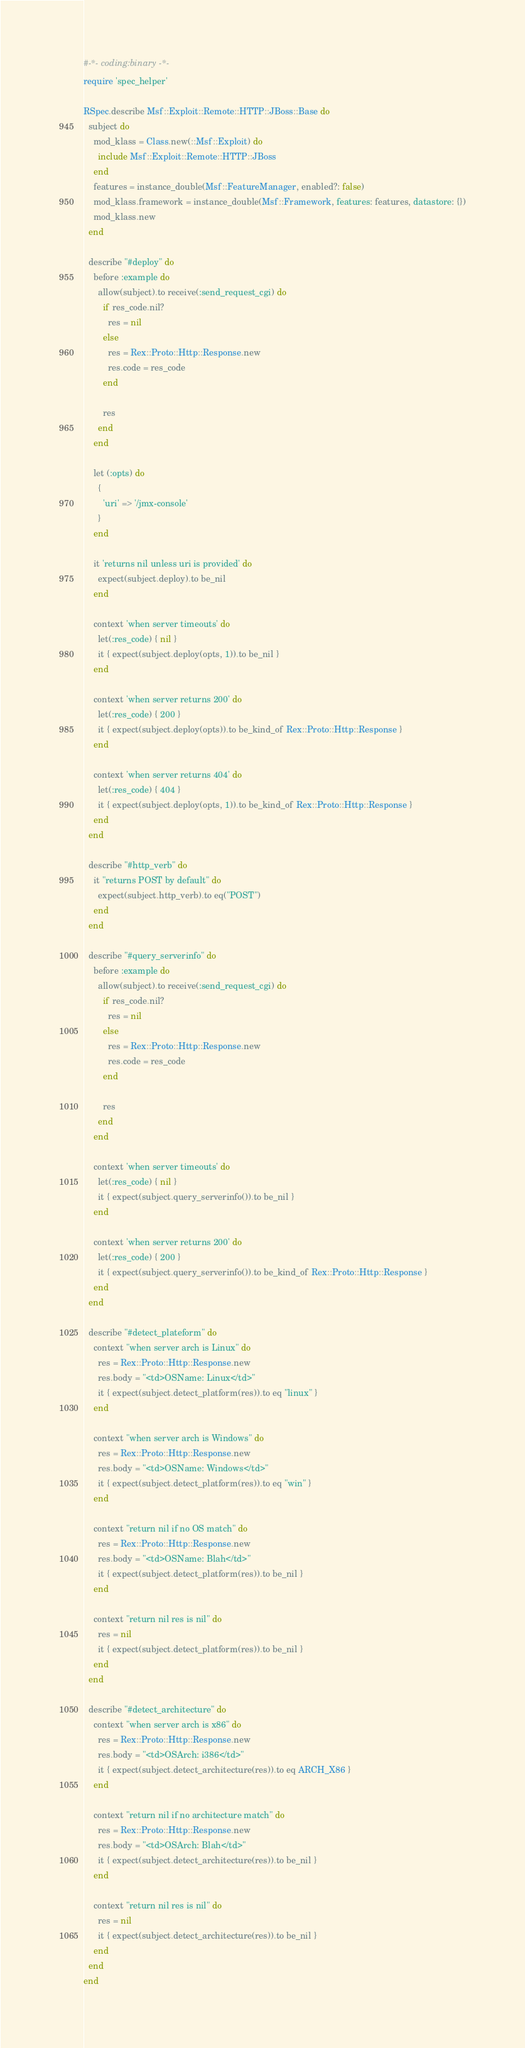Convert code to text. <code><loc_0><loc_0><loc_500><loc_500><_Ruby_>#-*- coding:binary -*-
require 'spec_helper'

RSpec.describe Msf::Exploit::Remote::HTTP::JBoss::Base do
  subject do
    mod_klass = Class.new(::Msf::Exploit) do
      include Msf::Exploit::Remote::HTTP::JBoss
    end
    features = instance_double(Msf::FeatureManager, enabled?: false)
    mod_klass.framework = instance_double(Msf::Framework, features: features, datastore: {})
    mod_klass.new
  end

  describe "#deploy" do
    before :example do
      allow(subject).to receive(:send_request_cgi) do
        if res_code.nil?
          res = nil
        else
          res = Rex::Proto::Http::Response.new
          res.code = res_code
        end

        res
      end
    end

    let (:opts) do
      {
        'uri' => '/jmx-console'
      }
    end

    it 'returns nil unless uri is provided' do
      expect(subject.deploy).to be_nil
    end

    context 'when server timeouts' do
      let(:res_code) { nil }
      it { expect(subject.deploy(opts, 1)).to be_nil }
    end

    context 'when server returns 200' do
      let(:res_code) { 200 }
      it { expect(subject.deploy(opts)).to be_kind_of Rex::Proto::Http::Response }
    end

    context 'when server returns 404' do
      let(:res_code) { 404 }
      it { expect(subject.deploy(opts, 1)).to be_kind_of Rex::Proto::Http::Response }
    end
  end

  describe "#http_verb" do
    it "returns POST by default" do
      expect(subject.http_verb).to eq("POST")
    end
  end

  describe "#query_serverinfo" do
    before :example do
      allow(subject).to receive(:send_request_cgi) do
        if res_code.nil?
          res = nil
        else
          res = Rex::Proto::Http::Response.new
          res.code = res_code
        end

        res
      end
    end

    context 'when server timeouts' do
      let(:res_code) { nil }
      it { expect(subject.query_serverinfo()).to be_nil }
    end

    context 'when server returns 200' do
      let(:res_code) { 200 }
      it { expect(subject.query_serverinfo()).to be_kind_of Rex::Proto::Http::Response }
    end
  end

  describe "#detect_plateform" do
    context "when server arch is Linux" do
      res = Rex::Proto::Http::Response.new
      res.body = "<td>OSName: Linux</td>"
      it { expect(subject.detect_platform(res)).to eq "linux" }
    end

    context "when server arch is Windows" do
      res = Rex::Proto::Http::Response.new
      res.body = "<td>OSName: Windows</td>"
      it { expect(subject.detect_platform(res)).to eq "win" }
    end

    context "return nil if no OS match" do
      res = Rex::Proto::Http::Response.new
      res.body = "<td>OSName: Blah</td>"
      it { expect(subject.detect_platform(res)).to be_nil }
    end

    context "return nil res is nil" do
      res = nil
      it { expect(subject.detect_platform(res)).to be_nil }
    end
  end

  describe "#detect_architecture" do
    context "when server arch is x86" do
      res = Rex::Proto::Http::Response.new
      res.body = "<td>OSArch: i386</td>"
      it { expect(subject.detect_architecture(res)).to eq ARCH_X86 }
    end

    context "return nil if no architecture match" do
      res = Rex::Proto::Http::Response.new
      res.body = "<td>OSArch: Blah</td>"
      it { expect(subject.detect_architecture(res)).to be_nil }
    end

    context "return nil res is nil" do
      res = nil
      it { expect(subject.detect_architecture(res)).to be_nil }
    end
  end
end
</code> 